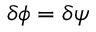Convert formula to latex. <formula><loc_0><loc_0><loc_500><loc_500>\delta \phi = \delta \psi</formula> 